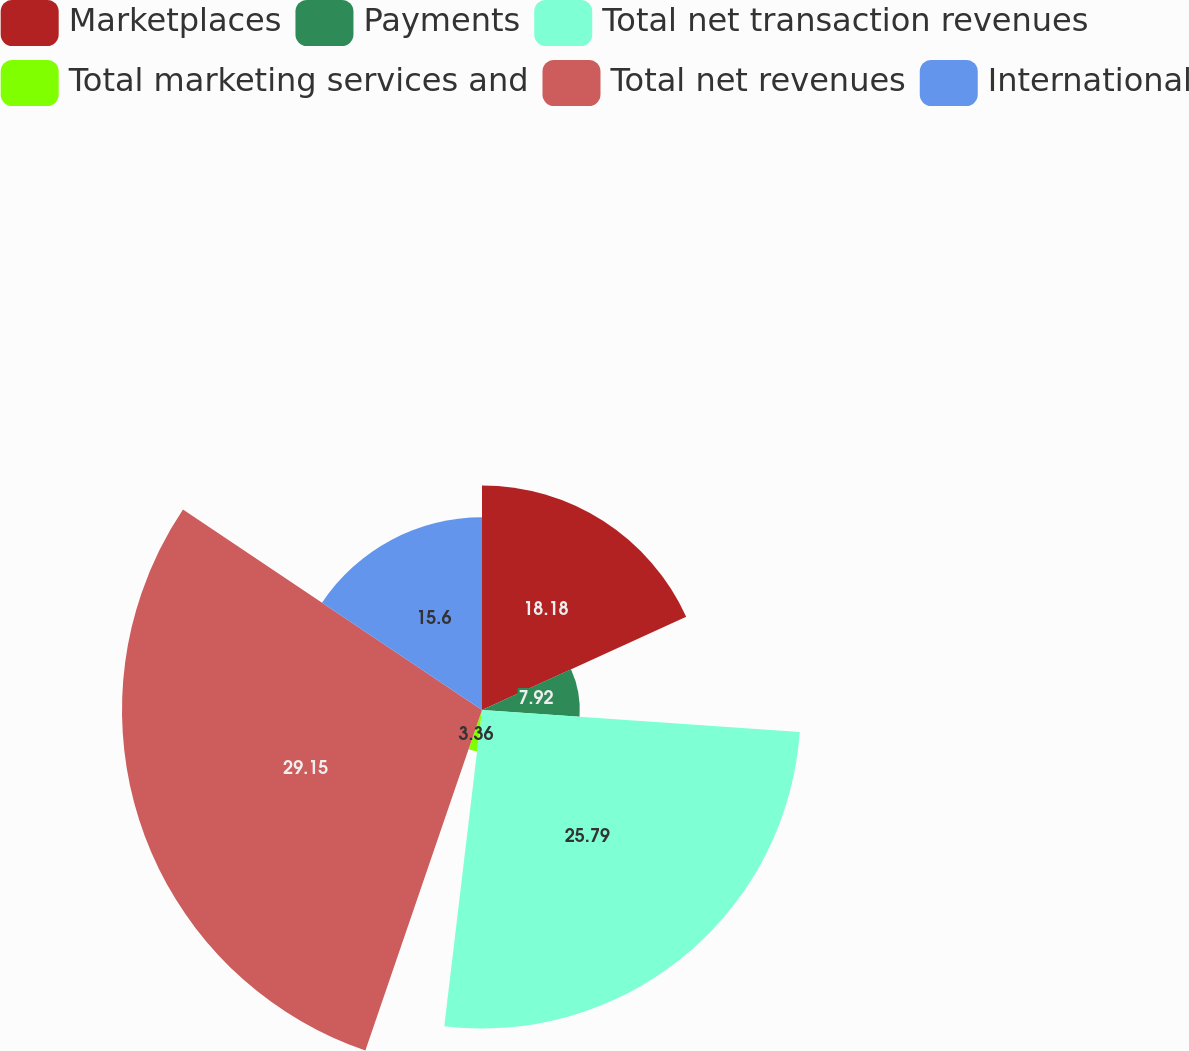Convert chart to OTSL. <chart><loc_0><loc_0><loc_500><loc_500><pie_chart><fcel>Marketplaces<fcel>Payments<fcel>Total net transaction revenues<fcel>Total marketing services and<fcel>Total net revenues<fcel>International<nl><fcel>18.18%<fcel>7.92%<fcel>25.79%<fcel>3.36%<fcel>29.15%<fcel>15.6%<nl></chart> 